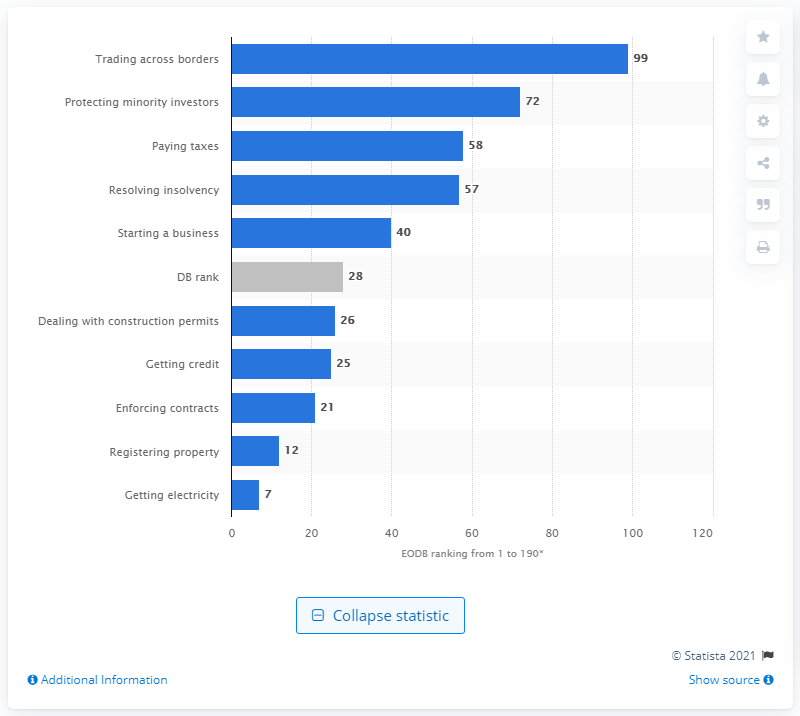Indicate a few pertinent items in this graphic. Russia scored 99 in the trading across borders category. 